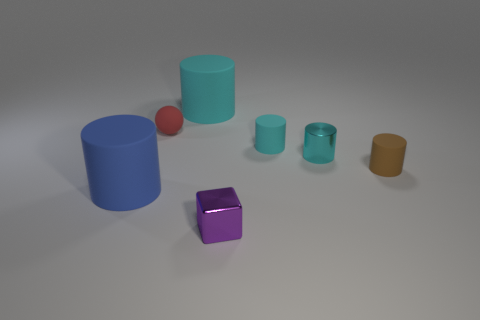Subtract all cyan balls. How many cyan cylinders are left? 3 Subtract all brown cylinders. How many cylinders are left? 4 Subtract all small cyan metal cylinders. How many cylinders are left? 4 Subtract all green cylinders. Subtract all green balls. How many cylinders are left? 5 Add 2 tiny brown cylinders. How many objects exist? 9 Subtract all cylinders. How many objects are left? 2 Subtract 1 brown cylinders. How many objects are left? 6 Subtract all small yellow matte cylinders. Subtract all big blue cylinders. How many objects are left? 6 Add 1 purple cubes. How many purple cubes are left? 2 Add 4 small blocks. How many small blocks exist? 5 